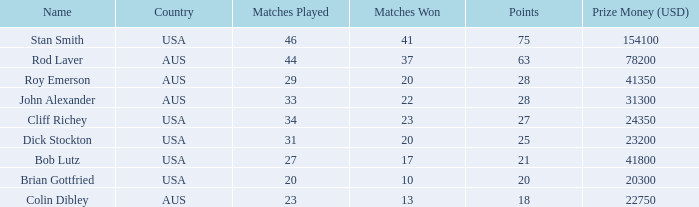For the athlete who played 23 matches, how many were won? 13.0. 